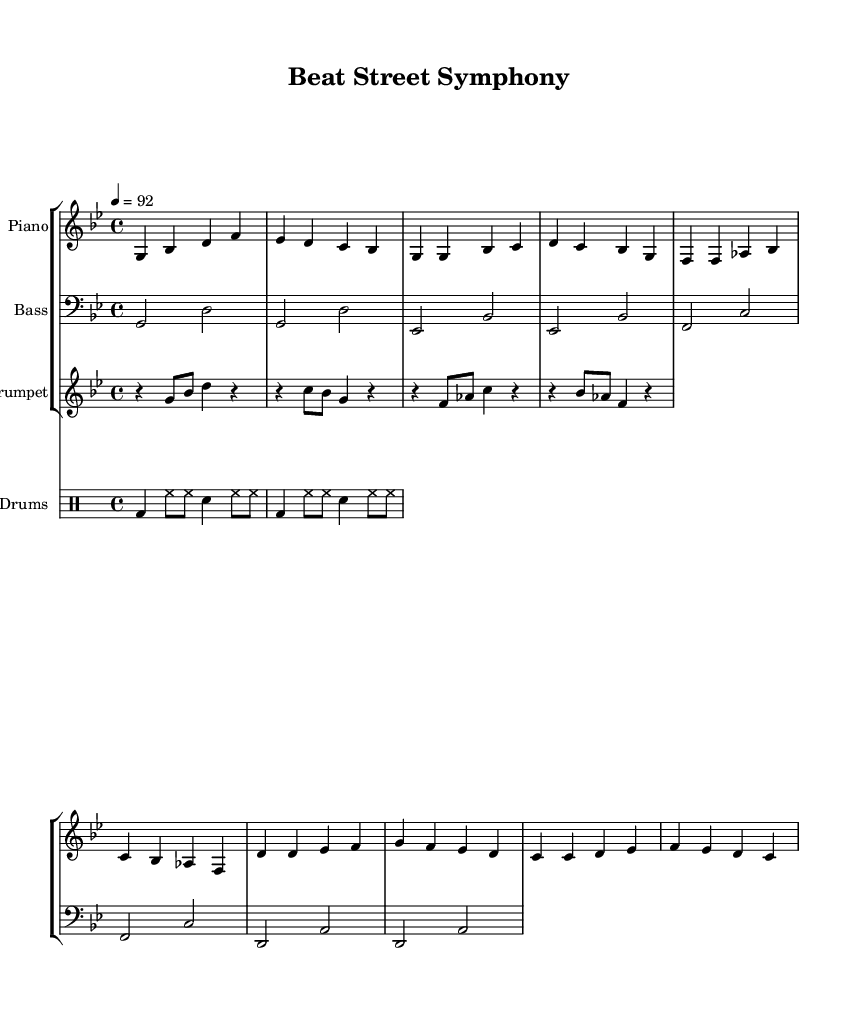What is the key signature of this music? The key signature is indicated at the beginning of the staff, where there are two flats, B flat and E flat. This means the music is set in G minor, which has two flats.
Answer: G minor What is the time signature of this music? The time signature is located right after the key signature, shown as "4/4." This means there are four beats in a measure and a quarter note gets one beat.
Answer: 4/4 What is the tempo marking? The tempo is written at the beginning of the score, showing "4 = 92," which means the quarter note should be played at a speed of 92 beats per minute.
Answer: 92 How many measures are in the chorus section? The chorus section consists of the lines that are marked with distinct patterns and typically repeated, totaling four measures in this score.
Answer: 4 What instruments are included in this composition? The score clearly labels three staffs for different instruments: Piano, Bass, and Trumpet. Additionally, there is a separate staff for Drums, indicating all the instruments featured.
Answer: Piano, Bass, Trumpet, Drums What rhythmic pattern do the drums primarily use? The drums' rhythmic pattern is shown in the drummode section, where the bass drums and hi-hat notes are detailed in an alternating pattern typical to beat-driven genres, emphasizing a steady pulse throughout the measures.
Answer: Bass drum and hi-hat 